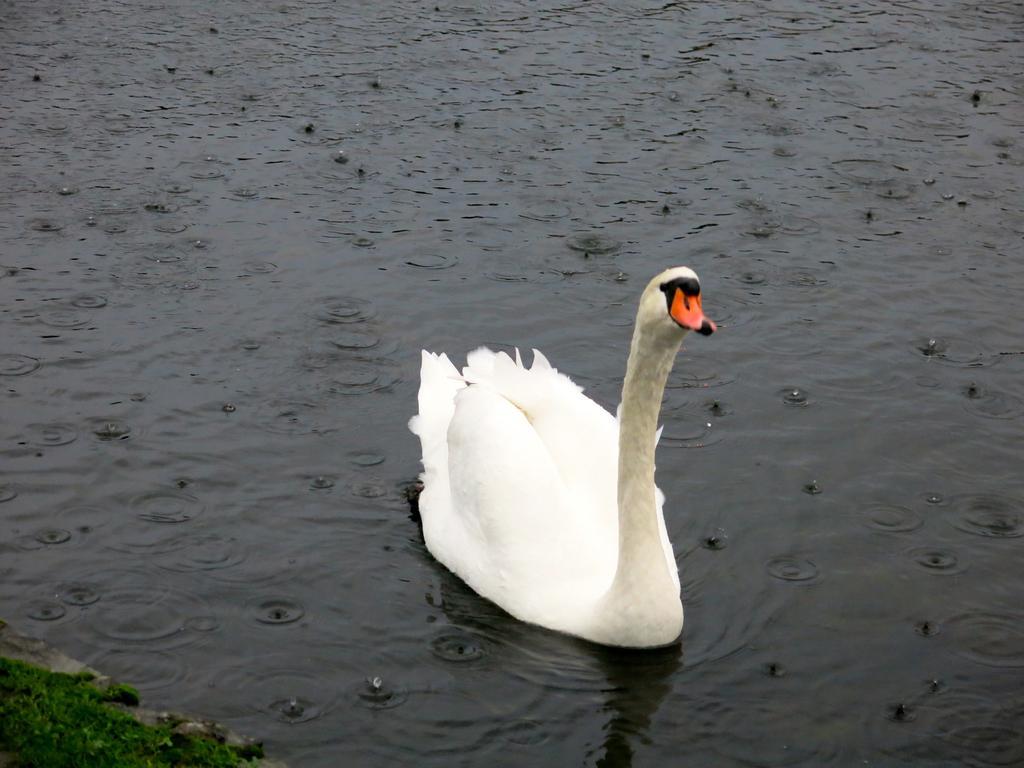Can you describe this image briefly? As we can see in the image there is water, grass and a white color bird. 